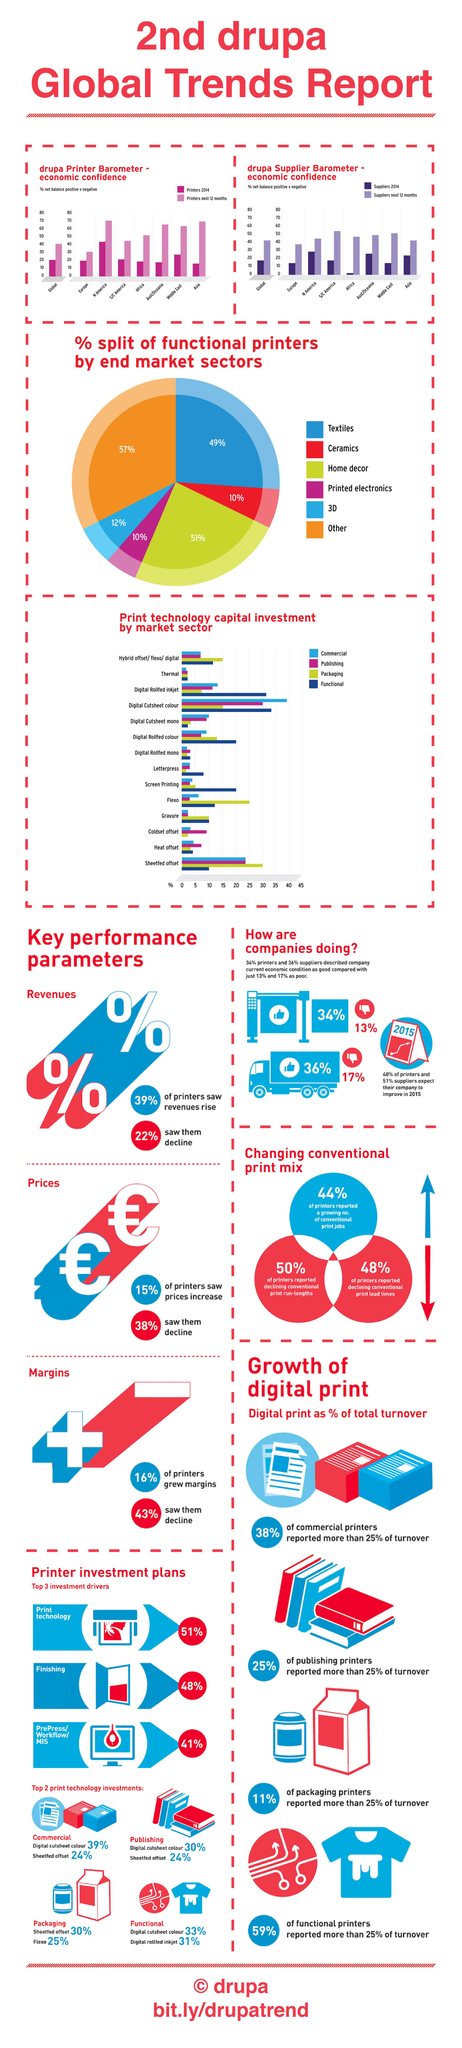Outline some significant characteristics in this image. The two print technology investments in packaging are Sheeted Offset and Flexo. The market sector with the lowest capital investment in functional print technology is thermal, followed by digital cutsheet monochrome, and finally, monochrome digital cutsheet. Letterpress is the market sector with the lowest capital investment in packaging print technology. The market sector that invests the most in capital technology for commercial printing is digital cutsheet color printing. The market sector that invests the most in capital technology for printing and publishing is digital cutsheet color. 